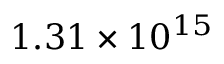<formula> <loc_0><loc_0><loc_500><loc_500>1 . 3 1 \times 1 0 ^ { 1 5 }</formula> 